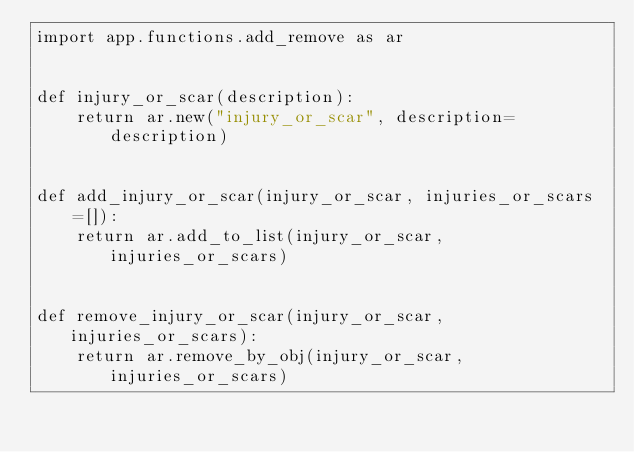Convert code to text. <code><loc_0><loc_0><loc_500><loc_500><_Python_>import app.functions.add_remove as ar


def injury_or_scar(description):
    return ar.new("injury_or_scar", description=description)


def add_injury_or_scar(injury_or_scar, injuries_or_scars=[]):
    return ar.add_to_list(injury_or_scar, injuries_or_scars)


def remove_injury_or_scar(injury_or_scar, injuries_or_scars):
    return ar.remove_by_obj(injury_or_scar, injuries_or_scars)
</code> 